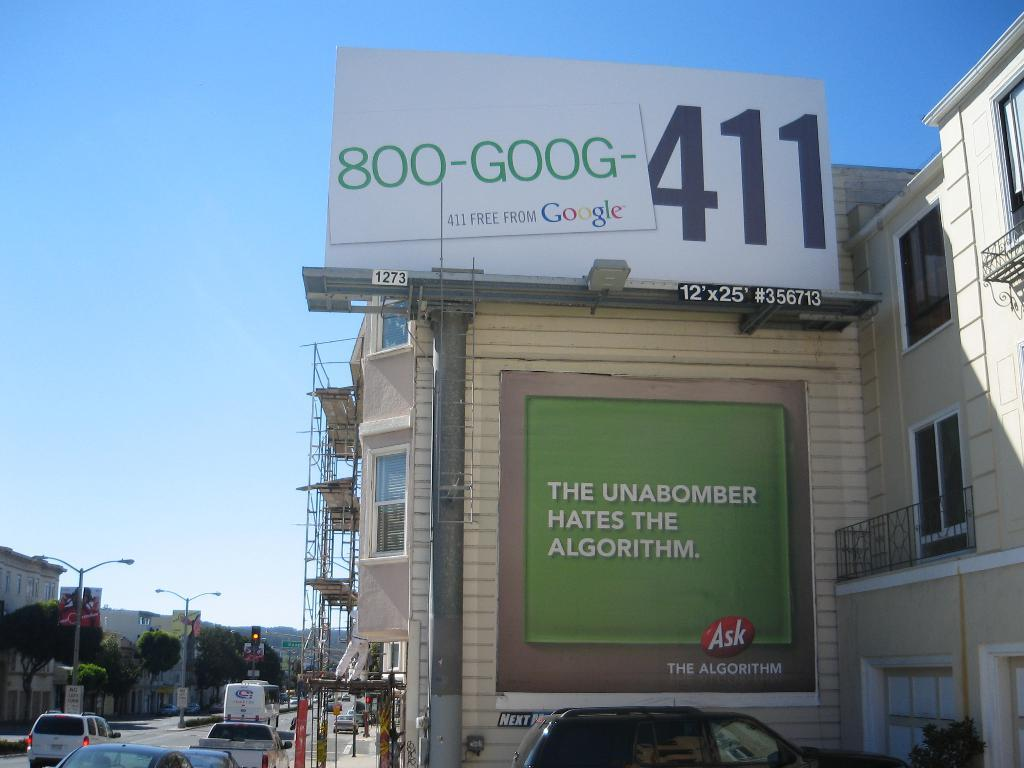<image>
Summarize the visual content of the image. a sign has the number 411 on it 